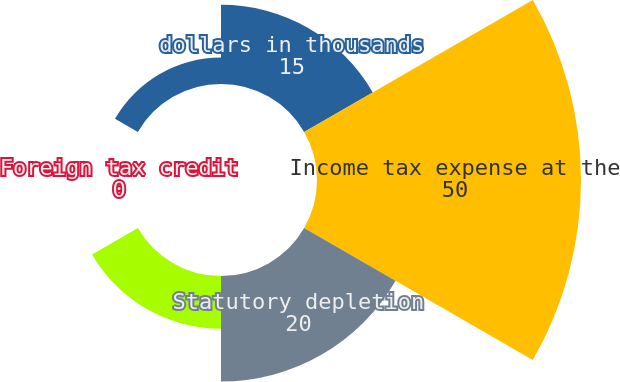<chart> <loc_0><loc_0><loc_500><loc_500><pie_chart><fcel>dollars in thousands<fcel>Income tax expense at the<fcel>Statutory depletion<fcel>Transition tax<fcel>Foreign tax credit<fcel>Other net<nl><fcel>15.0%<fcel>50.0%<fcel>20.0%<fcel>10.0%<fcel>0.0%<fcel>5.0%<nl></chart> 